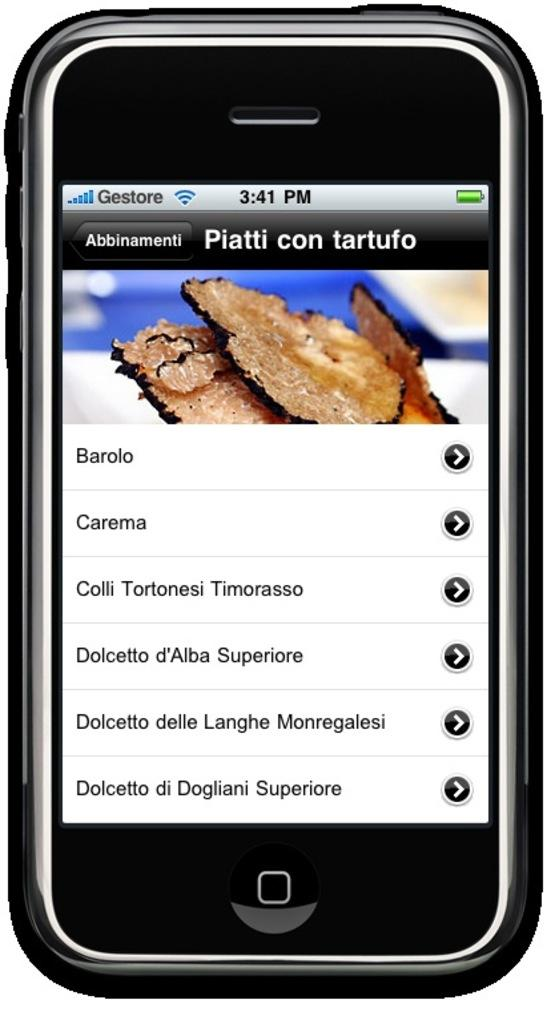<image>
Present a compact description of the photo's key features. Piatti con tartufo is displayed on a cellular phone screen at 3:41 pm. 